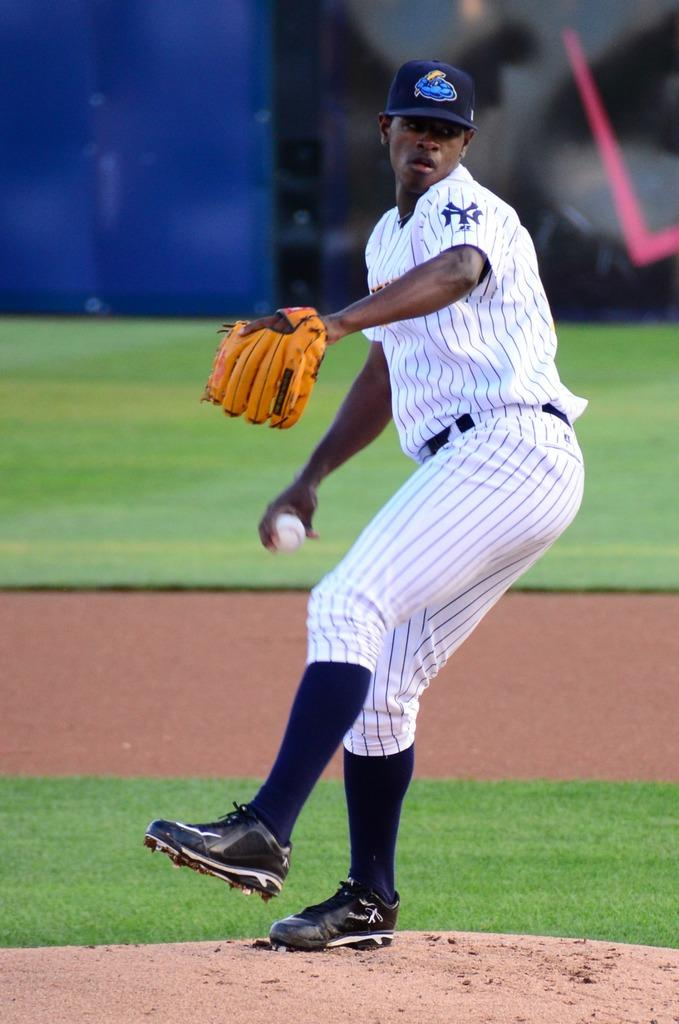Provide a one-sentence caption for the provided image. a NY Yankees baseball pitcher ready to throw a ball. 